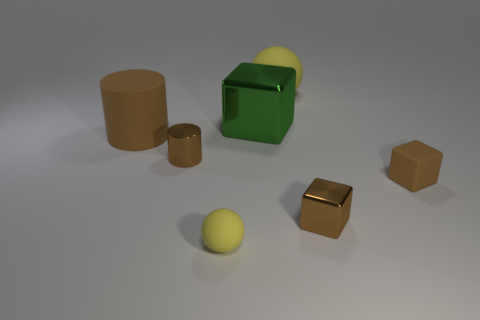What is the shape of the yellow thing that is to the left of the yellow ball right of the big green metallic block?
Make the answer very short. Sphere. Are there any other things that have the same color as the large cube?
Your response must be concise. No. Do the big metallic thing and the tiny rubber block have the same color?
Your response must be concise. No. How many cyan things are small rubber things or matte things?
Offer a terse response. 0. Is the number of brown metal objects that are on the right side of the big green cube less than the number of tiny metallic blocks?
Keep it short and to the point. No. What number of small brown matte things are left of the rubber thing in front of the small rubber block?
Your response must be concise. 0. What number of other objects are the same size as the shiny cylinder?
Ensure brevity in your answer.  3. How many things are green metallic blocks or tiny rubber things that are left of the big metallic cube?
Your answer should be compact. 2. Are there fewer brown metal objects than small brown metal cylinders?
Your answer should be compact. No. There is a big rubber thing that is behind the large thing on the left side of the small sphere; what is its color?
Ensure brevity in your answer.  Yellow. 